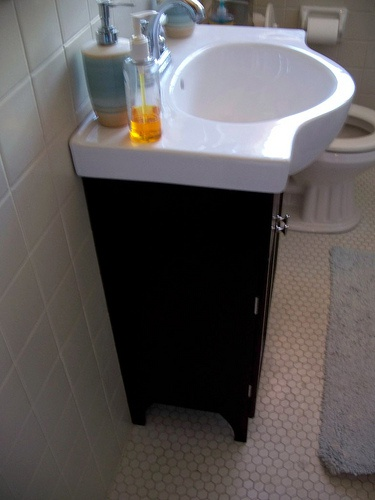Describe the objects in this image and their specific colors. I can see sink in black, darkgray, and lavender tones, toilet in black and gray tones, bottle in black, darkgray, gray, and red tones, and bottle in black, gray, purple, darkgray, and maroon tones in this image. 